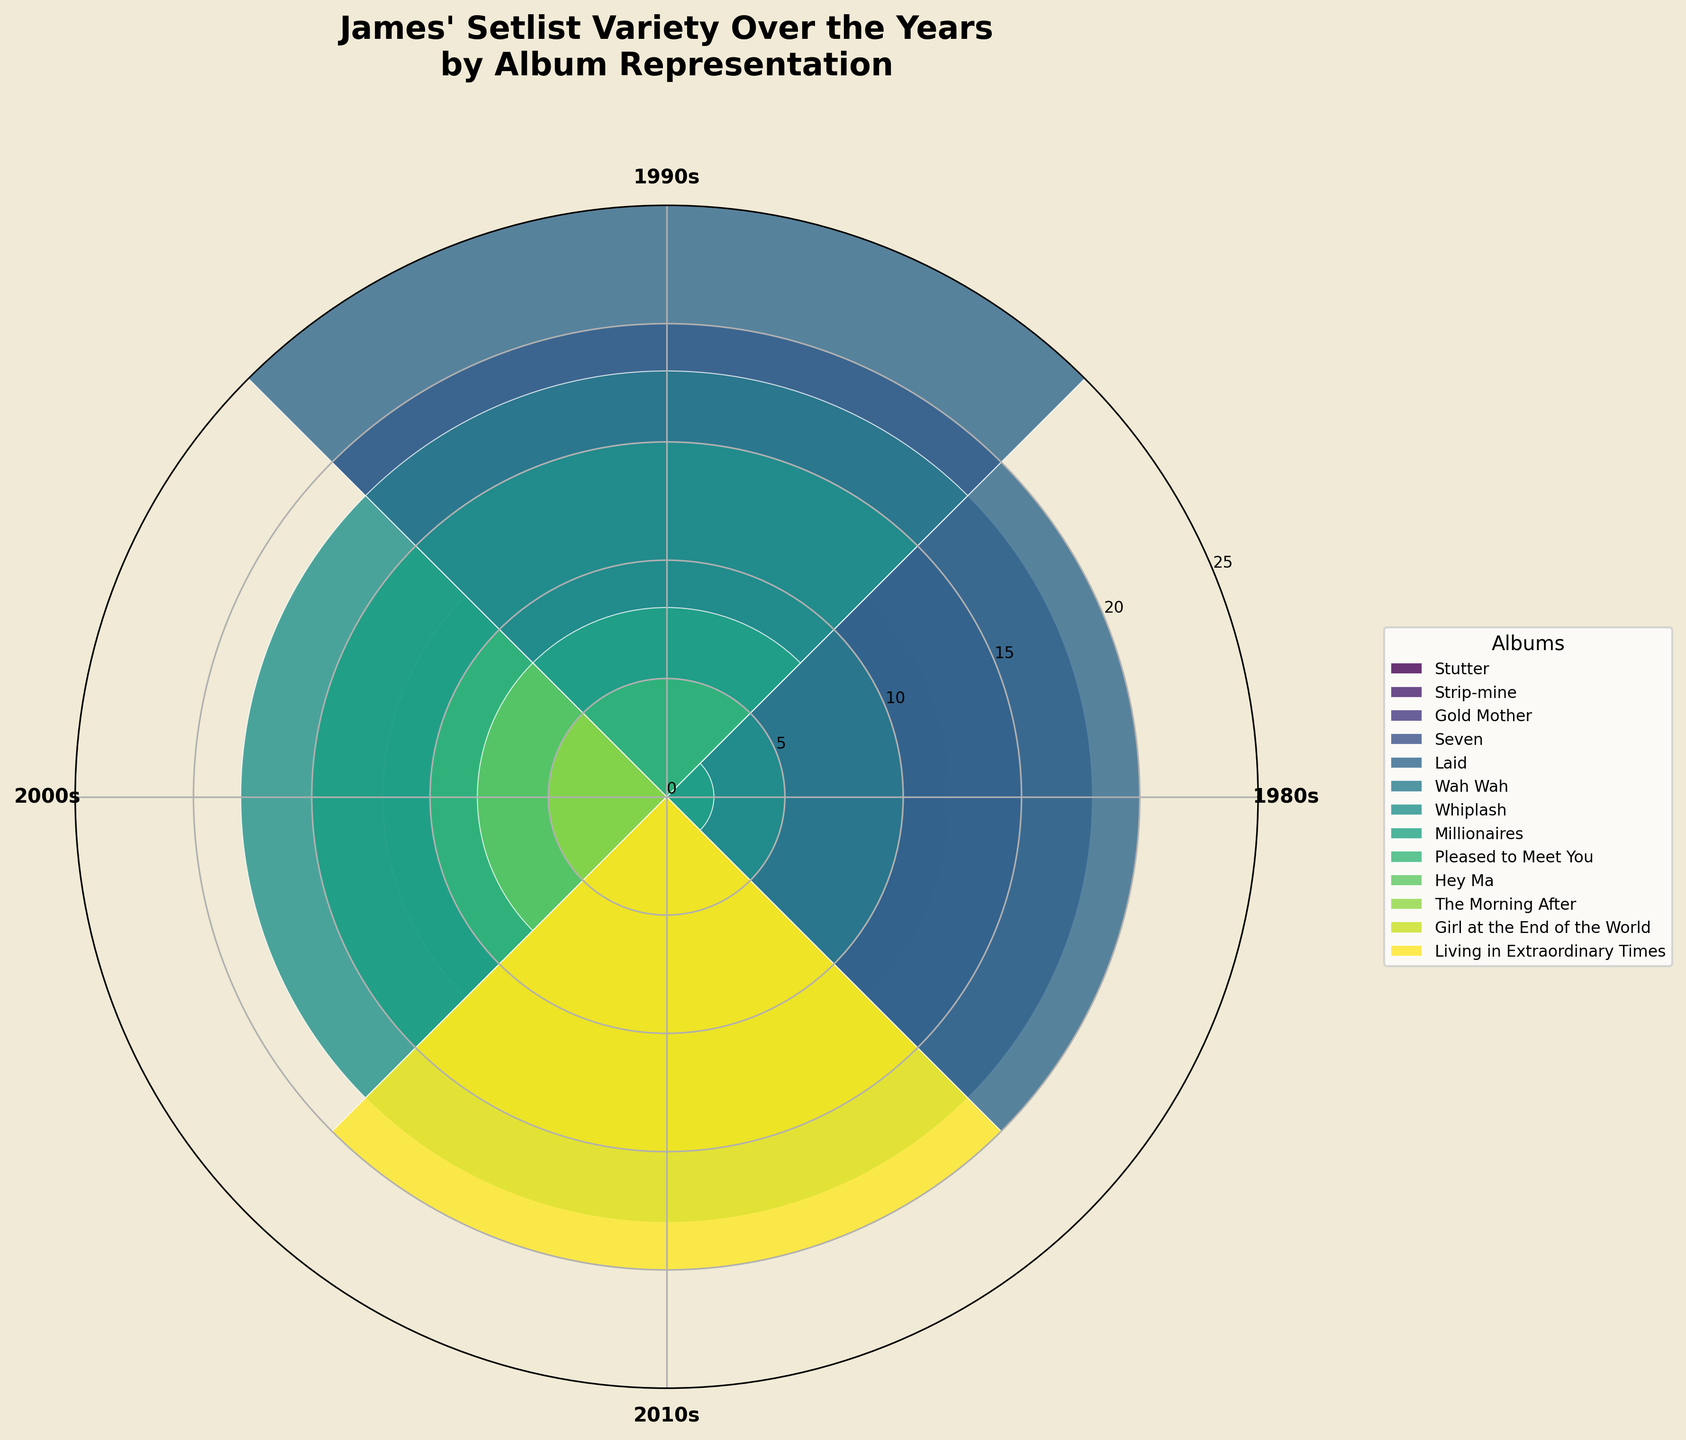What is the title of the polar area chart? The chart's title is prominently displayed at the top and it provides a summary of what the chart represents.
Answer: James' Setlist Variety Over the Years by Album Representation Which decade had the highest album representation for "Laid"? Look for the "Laid" album and identify which segment (decade) has the largest bar.
Answer: 1990s How many albums have representation in the 2010s decade? Count the number of bars (albums) that have non-zero values extending from the 2010s segment on the polar chart.
Answer: 7 What is the total representation of "Gold Mother" across all decades? Sum the heights of "Gold Mother" bars in each decade segment.
Answer: 15 + 20 + 10 + 5 = 50 Between "Seven" and "Whiplash", which album has more representation in live performances? Compare the height of the bars representing live performances for both "Seven" and "Whiplash".
Answer: Whiplash What is the difference in album representation between "Gold Mother" and "Stutter" in the 2000s? Subtract the height of "Stutter" bar from the "Gold Mother" bar in the 2000s segment.
Answer: 10 - 2 = 8 Which album has no representation until the 2010s decade? Identify the album or albums with all zero values in segments until the 2010s.
Answer: Hey Ma Calculate the average representation of "Living in Extraordinary Times" across all decades it is represented in. Sum the values for "Living in Extraordinary Times" and divide by the number of decades it is represented in.
Answer: 20/1 = 20 Which decade had the least number of albums represented? Count the number of albums represented in each decade segment and identify the one with the least count.
Answer: 1980s For the album "Strip-mine," how many more representations does it have in the 1990s compared to the 2000s? Subtract the representation value in the 2000s from the value in the 1990s for "Strip-mine".
Answer: 7 - 3 = 4 